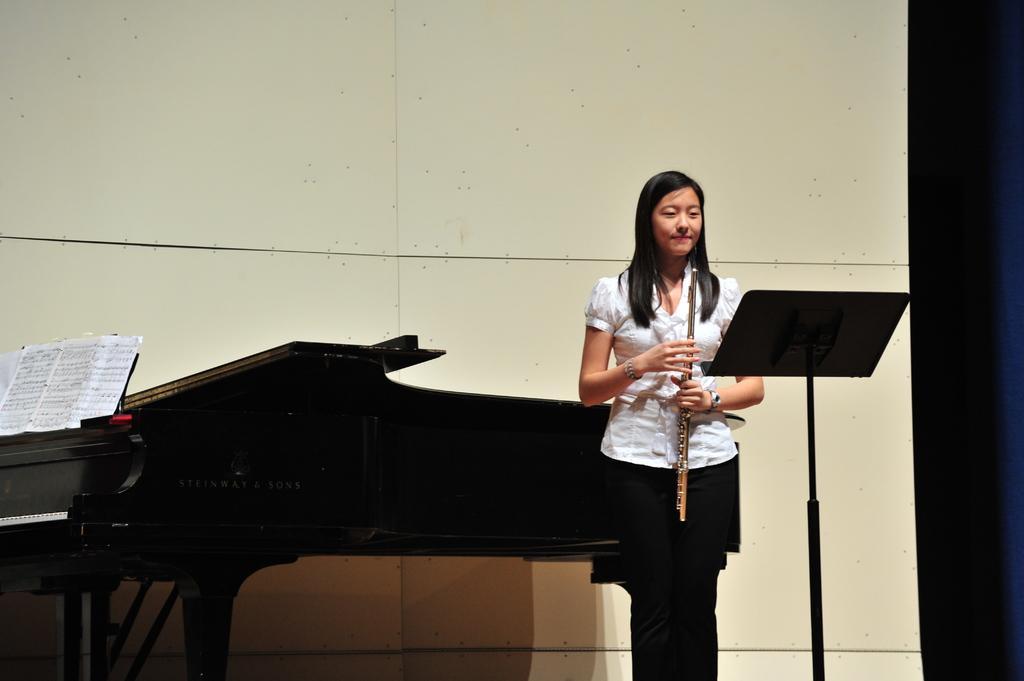Please provide a concise description of this image. This Picture describe about the a girl with black silky hairs wearing a white shirt black jean standing on the stage holding a flute in her hand. And in front a musical notes on the stand is kept. Beside the girl we can see black piano and a musical note attached to it. Behind a white panel board like wall is seen. 